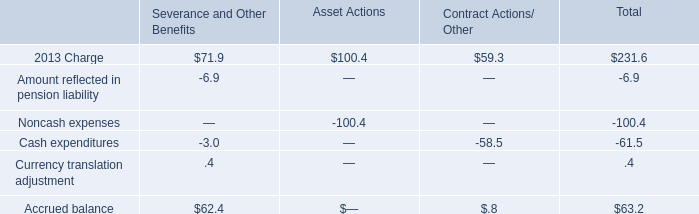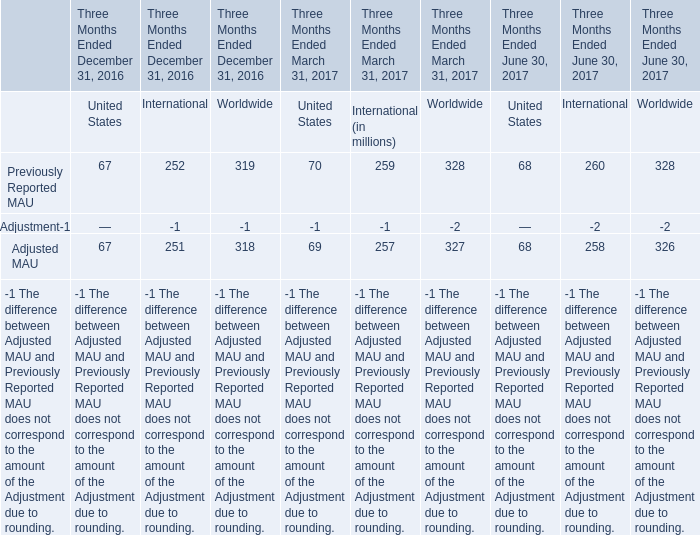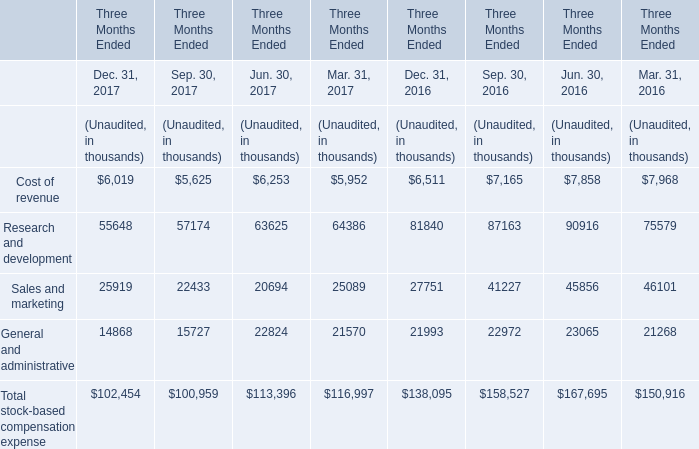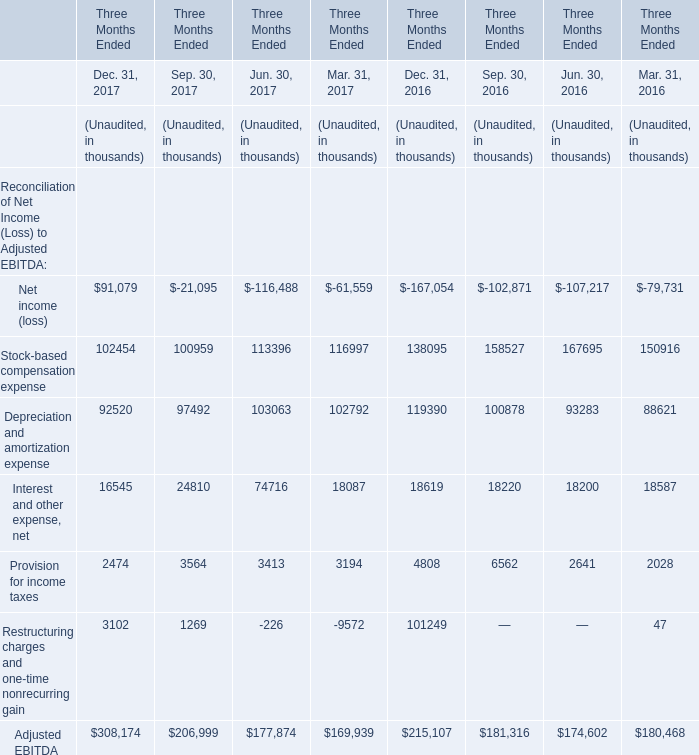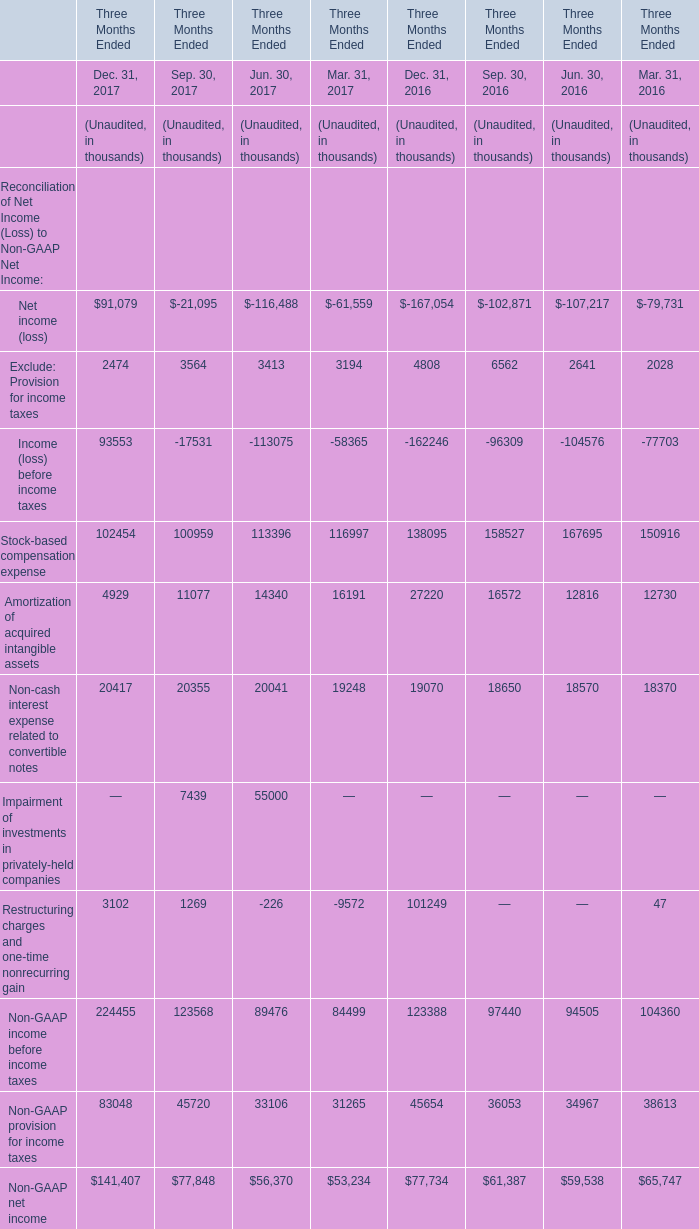What was the total amount of the Amortization of acquired intangible assets in the sections where Exclude: Provision for income taxes greater than 0? (in thousand) 
Computations: (((((((4929 + 11077) + 14340) + 16191) + 27220) + 16572) + 12816) + 12730)
Answer: 115875.0. 